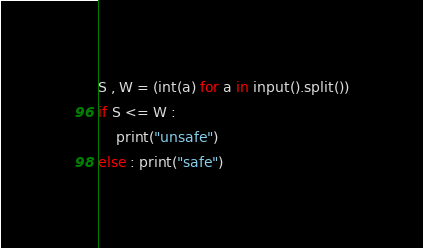Convert code to text. <code><loc_0><loc_0><loc_500><loc_500><_Python_>S , W = (int(a) for a in input().split())
if S <= W :
    print("unsafe")
else : print("safe")</code> 